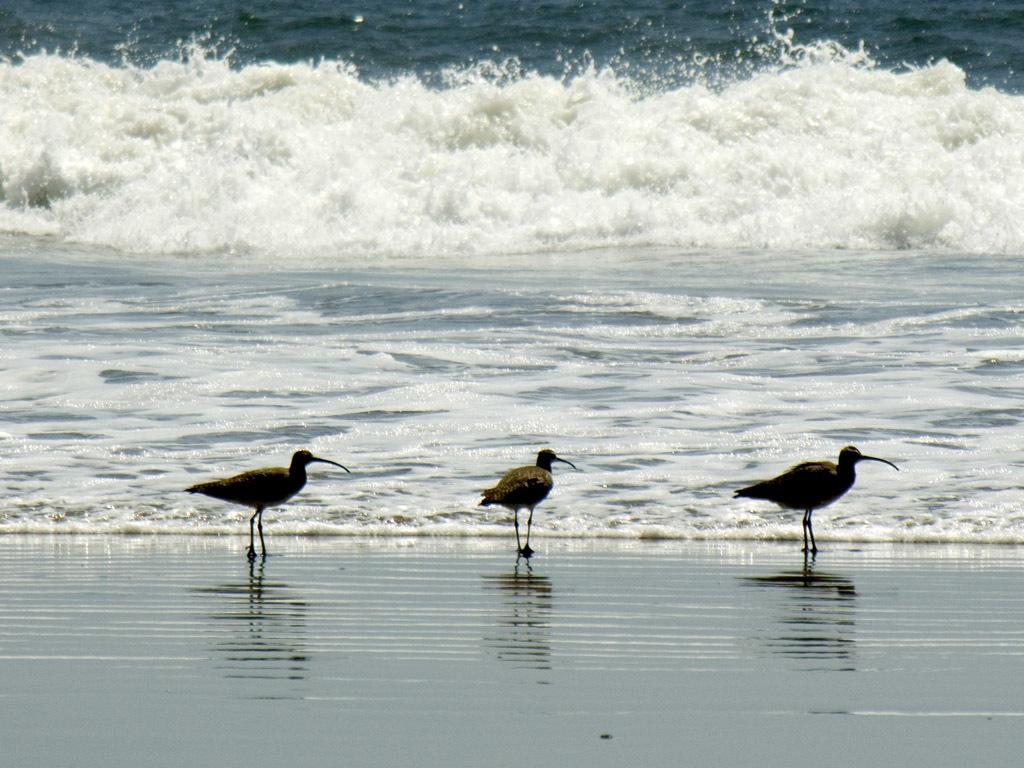What type of animals can be seen in the image? Birds can be seen in the image. What is the primary element in which the birds are situated? The birds are situated in water. What type of bike can be seen in the image? There is no bike present in the image; it features birds in water. What type of tooth can be seen in the image? There are no teeth present in the image, as it features birds in water. 